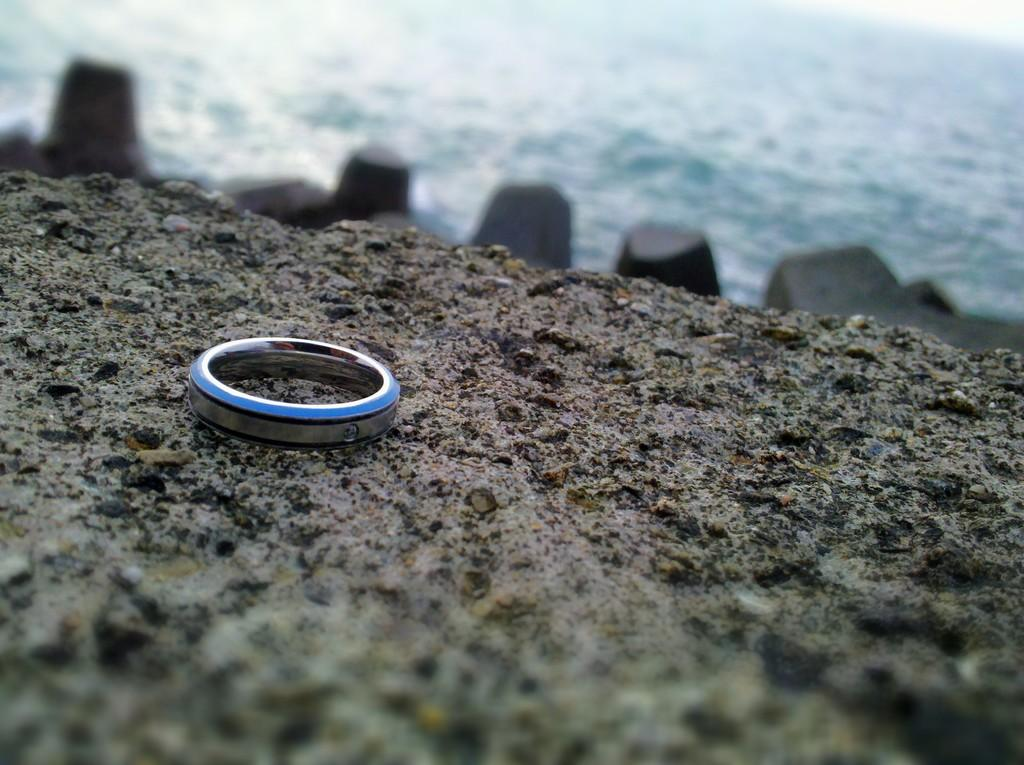What is the main subject in the center of the image? There is an object in the center of the image. What can be seen at the bottom of the image? The ground is visible at the bottom of the image. What type of natural elements are present in the middle of the image? There are rocks in the middle of the image. What is visible at the top of the image? Water is present at the top of the image. What type of music is being played by the lawyer in the news in the image? There is no music, lawyer, or news present in the image. 